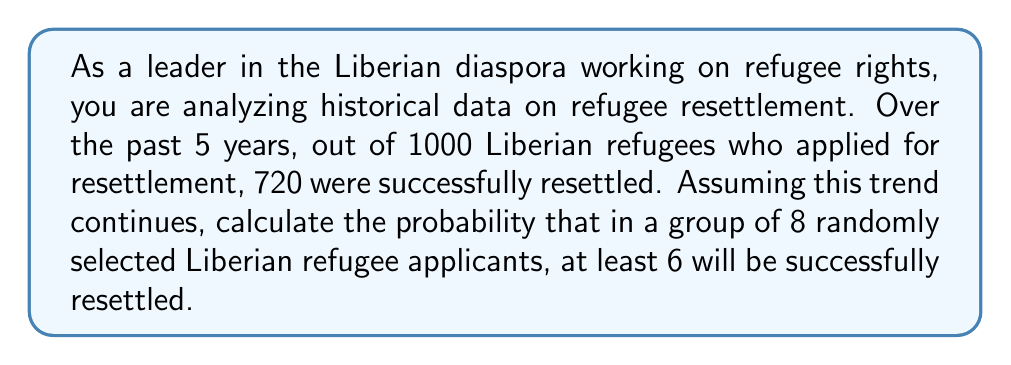Could you help me with this problem? To solve this problem, we'll use the binomial probability distribution, as we're dealing with a fixed number of independent trials (refugee applications) with two possible outcomes (success or failure).

Let's define our variables:
$n = 8$ (number of refugee applicants)
$p = 720/1000 = 0.72$ (probability of successful resettlement)
$q = 1 - p = 0.28$ (probability of unsuccessful resettlement)

We need to find $P(X \geq 6)$, where $X$ is the number of successful resettlements.

This can be calculated as:
$P(X \geq 6) = P(X = 6) + P(X = 7) + P(X = 8)$

The binomial probability formula is:
$P(X = k) = \binom{n}{k} p^k q^{n-k}$

Let's calculate each probability:

1) $P(X = 6) = \binom{8}{6} (0.72)^6 (0.28)^2$
   $= 28 \cdot 0.1780 \cdot 0.0784 = 0.3898$

2) $P(X = 7) = \binom{8}{7} (0.72)^7 (0.28)^1$
   $= 8 \cdot 0.2472 \cdot 0.28 = 0.5537$

3) $P(X = 8) = \binom{8}{8} (0.72)^8 (0.28)^0$
   $= 1 \cdot 0.3432 \cdot 1 = 0.3432$

Now, we sum these probabilities:
$P(X \geq 6) = 0.3898 + 0.5537 + 0.3432 = 1.2867$

Therefore, the probability that at least 6 out of 8 randomly selected Liberian refugee applicants will be successfully resettled is approximately 0.2867 or 28.67%.
Answer: $P(X \geq 6) \approx 0.2867$ or $28.67\%$ 